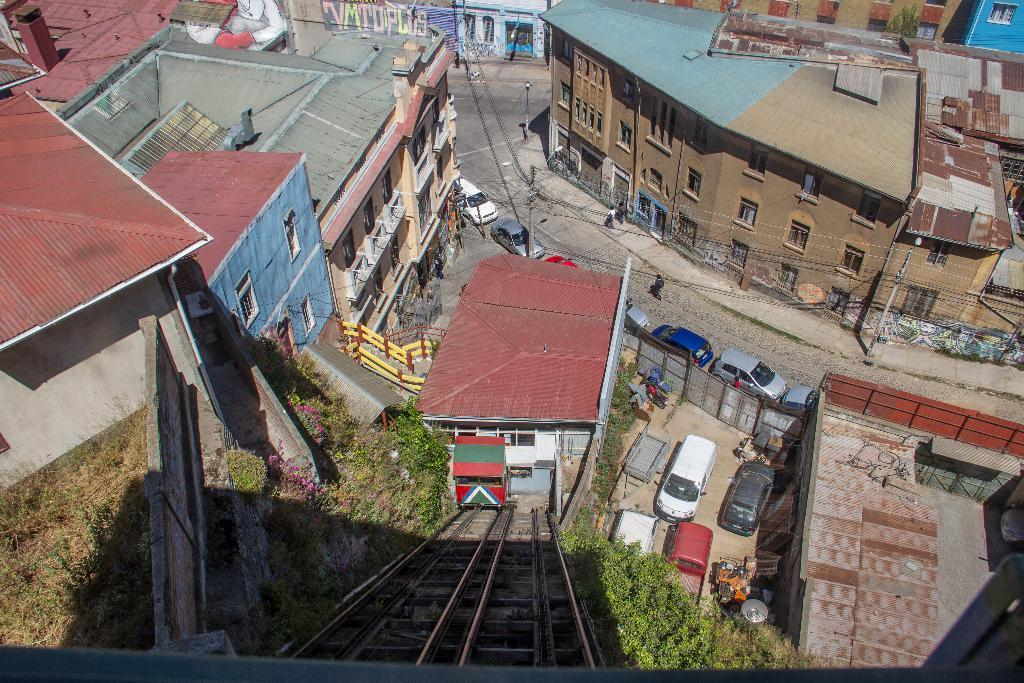What can be seen on the road in the image? There are cars parked on the road in the image. What is visible in the distance behind the parked cars? There are many buildings and plants visible in the background of the image. How many quarters can be seen on the hill in the image? There is no hill or quarters present in the image. 